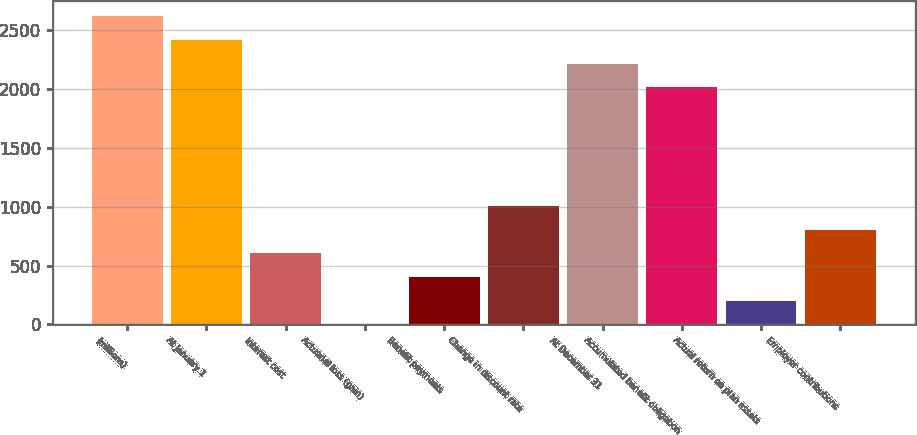Convert chart to OTSL. <chart><loc_0><loc_0><loc_500><loc_500><bar_chart><fcel>(millions)<fcel>At January 1<fcel>Interest cost<fcel>Actuarial loss (gain)<fcel>Benefit payments<fcel>Change in discount rate<fcel>At December 31<fcel>Accumulated benefit obligation<fcel>Actual return on plan assets<fcel>Employer contributions<nl><fcel>2616.6<fcel>2415.4<fcel>604.6<fcel>1<fcel>403.4<fcel>1007<fcel>2214.2<fcel>2013<fcel>202.2<fcel>805.8<nl></chart> 